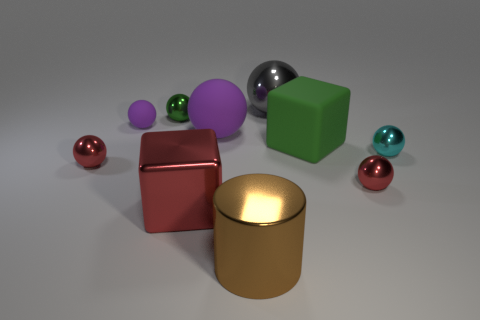What number of gray objects are the same size as the matte cube?
Provide a short and direct response. 1. What shape is the thing that is the same color as the large rubber sphere?
Provide a short and direct response. Sphere. The tiny red object that is on the left side of the large red metallic cube that is to the right of the thing to the left of the tiny purple sphere is what shape?
Provide a short and direct response. Sphere. The big cube behind the cyan shiny sphere is what color?
Provide a short and direct response. Green. How many things are either big blocks that are on the left side of the big matte sphere or metal objects that are left of the small cyan ball?
Offer a very short reply. 6. What number of other large objects are the same shape as the gray shiny thing?
Make the answer very short. 1. What is the color of the cylinder that is the same size as the red block?
Provide a short and direct response. Brown. The object in front of the red metal thing in front of the small red metal thing to the right of the red metal cube is what color?
Provide a short and direct response. Brown. There is a green rubber object; is it the same size as the red sphere that is left of the large brown metal cylinder?
Keep it short and to the point. No. How many things are either purple cubes or brown cylinders?
Your response must be concise. 1. 